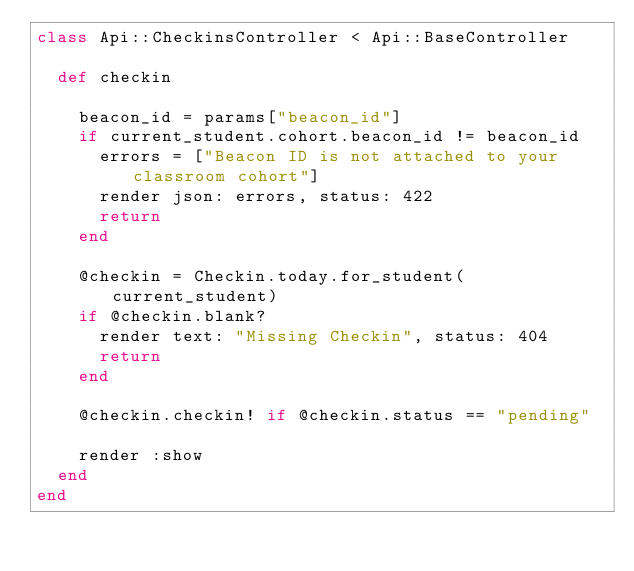<code> <loc_0><loc_0><loc_500><loc_500><_Ruby_>class Api::CheckinsController < Api::BaseController

  def checkin

    beacon_id = params["beacon_id"]
    if current_student.cohort.beacon_id != beacon_id
      errors = ["Beacon ID is not attached to your classroom cohort"]
      render json: errors, status: 422
      return
    end

    @checkin = Checkin.today.for_student(current_student)
    if @checkin.blank?
      render text: "Missing Checkin", status: 404
      return
    end

    @checkin.checkin! if @checkin.status == "pending"

    render :show
  end
end
</code> 